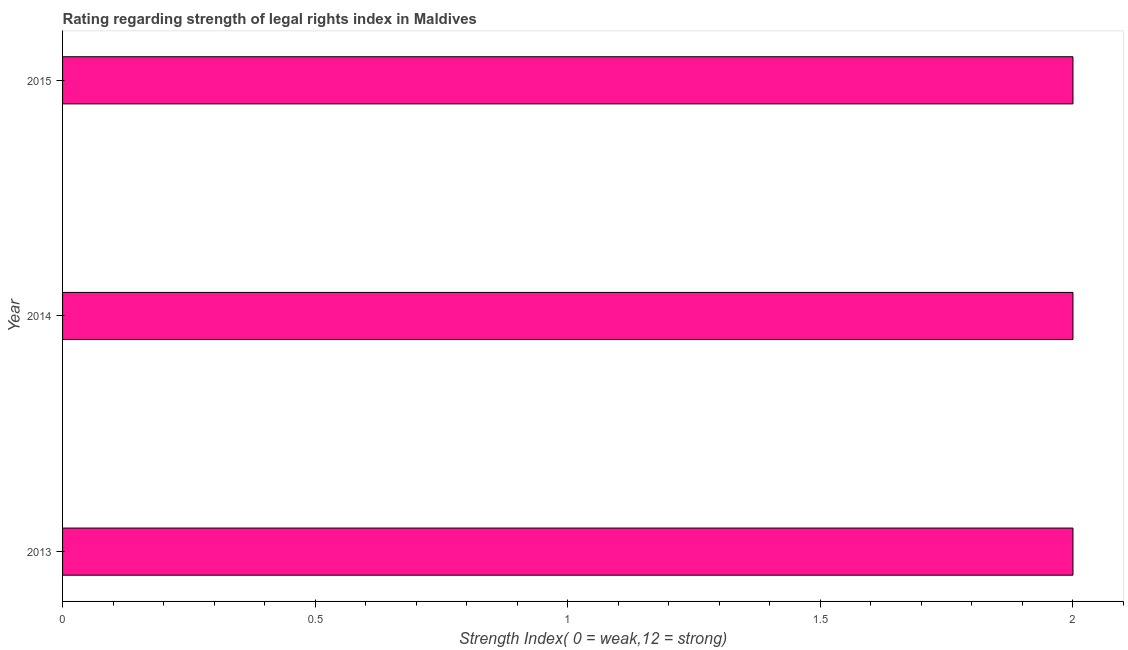Does the graph contain any zero values?
Your response must be concise. No. Does the graph contain grids?
Your response must be concise. No. What is the title of the graph?
Your response must be concise. Rating regarding strength of legal rights index in Maldives. What is the label or title of the X-axis?
Your answer should be compact. Strength Index( 0 = weak,12 = strong). What is the label or title of the Y-axis?
Offer a terse response. Year. What is the strength of legal rights index in 2014?
Your response must be concise. 2. Across all years, what is the maximum strength of legal rights index?
Provide a short and direct response. 2. Across all years, what is the minimum strength of legal rights index?
Offer a terse response. 2. In which year was the strength of legal rights index minimum?
Offer a very short reply. 2013. What is the sum of the strength of legal rights index?
Your answer should be compact. 6. What is the difference between the strength of legal rights index in 2013 and 2015?
Ensure brevity in your answer.  0. In how many years, is the strength of legal rights index greater than 0.5 ?
Provide a succinct answer. 3. Do a majority of the years between 2015 and 2014 (inclusive) have strength of legal rights index greater than 0.1 ?
Ensure brevity in your answer.  No. Is the difference between the strength of legal rights index in 2013 and 2015 greater than the difference between any two years?
Make the answer very short. Yes. What is the difference between the highest and the second highest strength of legal rights index?
Keep it short and to the point. 0. Is the sum of the strength of legal rights index in 2013 and 2015 greater than the maximum strength of legal rights index across all years?
Your response must be concise. Yes. What is the difference between the highest and the lowest strength of legal rights index?
Your answer should be compact. 0. How many bars are there?
Your answer should be compact. 3. Are all the bars in the graph horizontal?
Give a very brief answer. Yes. How many years are there in the graph?
Your answer should be very brief. 3. Are the values on the major ticks of X-axis written in scientific E-notation?
Your answer should be very brief. No. What is the Strength Index( 0 = weak,12 = strong) of 2013?
Offer a terse response. 2. What is the difference between the Strength Index( 0 = weak,12 = strong) in 2013 and 2014?
Keep it short and to the point. 0. What is the difference between the Strength Index( 0 = weak,12 = strong) in 2013 and 2015?
Offer a very short reply. 0. What is the ratio of the Strength Index( 0 = weak,12 = strong) in 2013 to that in 2014?
Your answer should be compact. 1. 